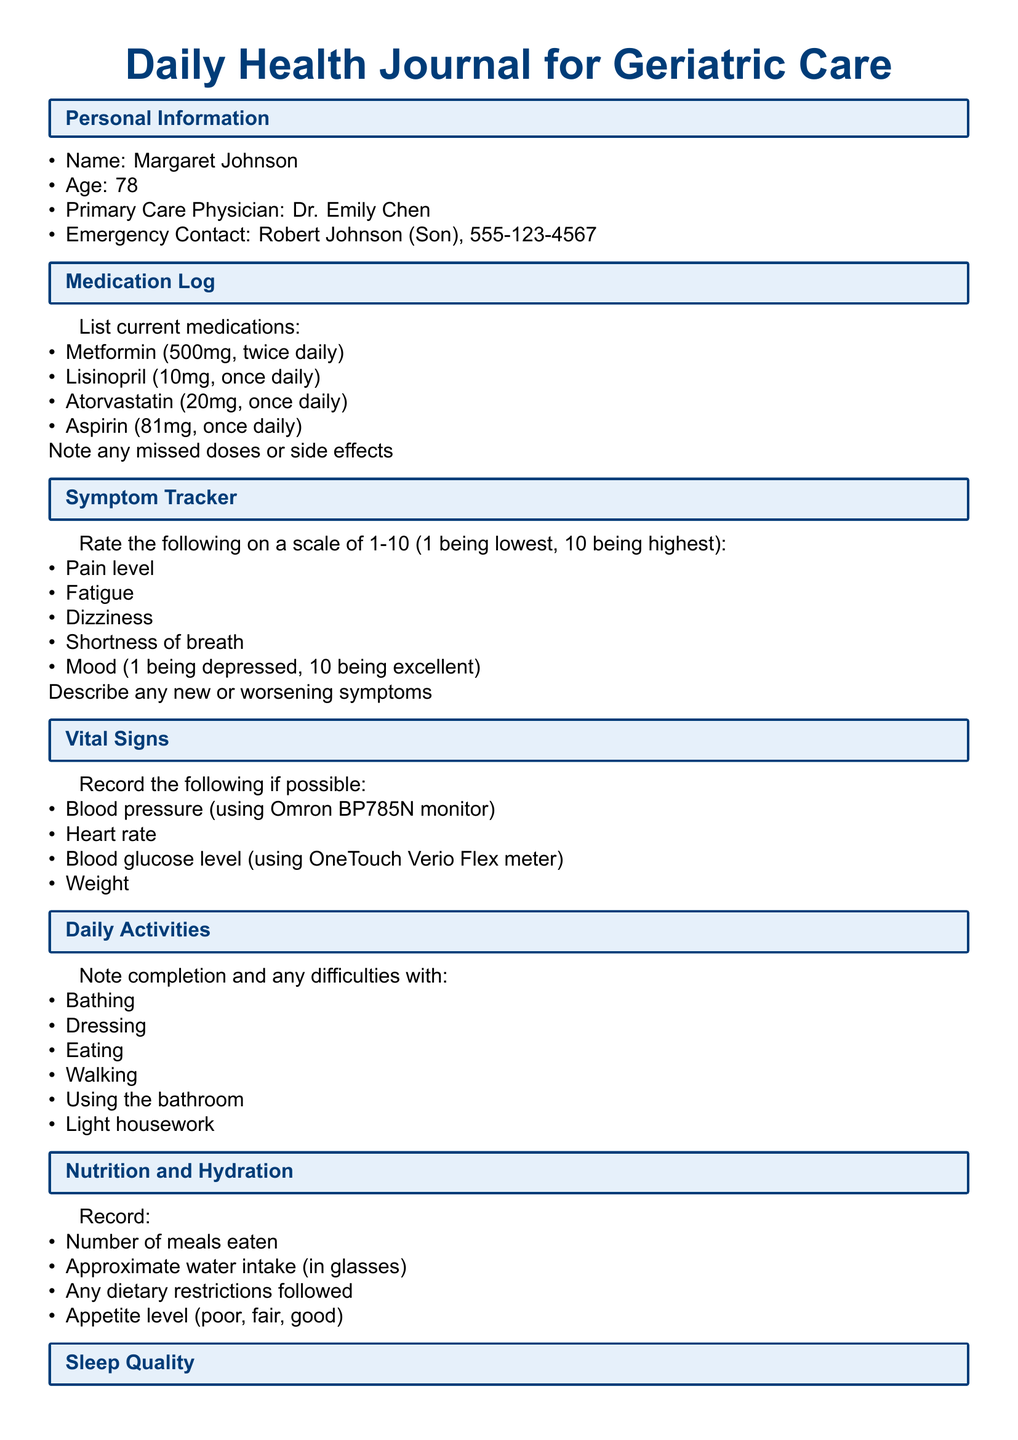What is the name of the primary care physician? The primary care physician's name is mentioned in the personal information section.
Answer: Dr. Emily Chen How old is Margaret Johnson? Margaret Johnson's age is explicitly stated in the personal information section.
Answer: 78 What medication is taken twice daily? The medication log lists medications along with their dosages and frequencies.
Answer: Metformin What is the blood pressure monitor used? The vital signs section specifies the equipment for monitoring blood pressure.
Answer: Omron BP785N What is the date of the next cardiology appointment? The upcoming appointments section lists scheduled healthcare visits with their dates.
Answer: June 2, 2023 On a scale of 1-10, what does a rating of 1 signify for mood? The symptom tracker section provides a rating scale where 1 represents the lowest mood.
Answer: Depressed What activities are noted for daily difficulties? The daily activities section specifies common tasks where difficulties may occur.
Answer: Bathing What type of exercise is suggested in the physical activity section? The physical activity section lists types of exercises suitable for geriatric care.
Answer: Chair yoga What dietary restrictions are mentioned? The nutrition and hydration section asks for input on dietary restrictions, indicating they need to be recorded.
Answer: Any dietary restrictions followed 